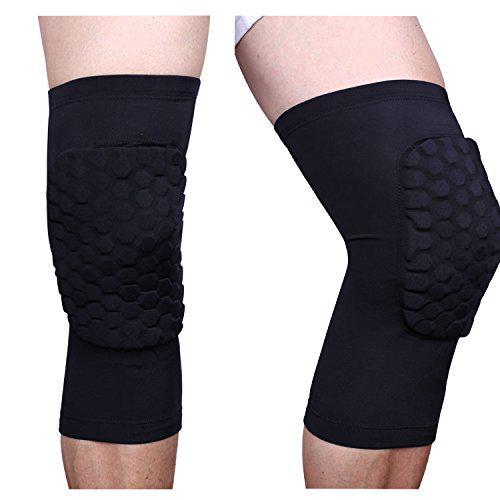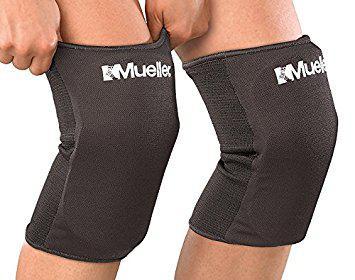The first image is the image on the left, the second image is the image on the right. Analyze the images presented: Is the assertion "In total, there are 4 knees covered by black knee guards." valid? Answer yes or no. Yes. The first image is the image on the left, the second image is the image on the right. For the images displayed, is the sentence "There are two sets of matching knee pads being worn by two people." factually correct? Answer yes or no. Yes. 